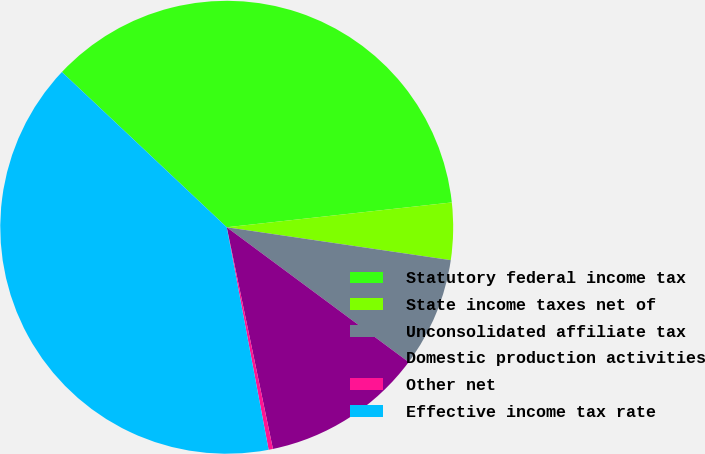Convert chart to OTSL. <chart><loc_0><loc_0><loc_500><loc_500><pie_chart><fcel>Statutory federal income tax<fcel>State income taxes net of<fcel>Unconsolidated affiliate tax<fcel>Domestic production activities<fcel>Other net<fcel>Effective income tax rate<nl><fcel>36.23%<fcel>4.07%<fcel>7.83%<fcel>11.58%<fcel>0.31%<fcel>39.99%<nl></chart> 